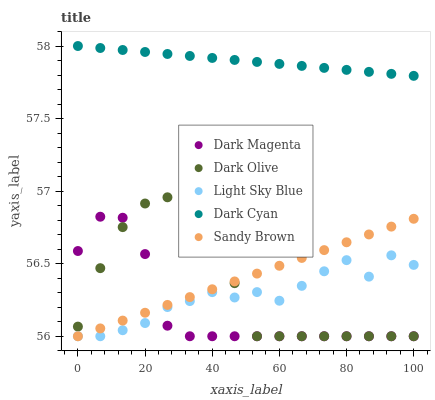Does Dark Magenta have the minimum area under the curve?
Answer yes or no. Yes. Does Dark Cyan have the maximum area under the curve?
Answer yes or no. Yes. Does Dark Olive have the minimum area under the curve?
Answer yes or no. No. Does Dark Olive have the maximum area under the curve?
Answer yes or no. No. Is Sandy Brown the smoothest?
Answer yes or no. Yes. Is Light Sky Blue the roughest?
Answer yes or no. Yes. Is Dark Olive the smoothest?
Answer yes or no. No. Is Dark Olive the roughest?
Answer yes or no. No. Does Dark Olive have the lowest value?
Answer yes or no. Yes. Does Dark Cyan have the highest value?
Answer yes or no. Yes. Does Dark Olive have the highest value?
Answer yes or no. No. Is Dark Olive less than Dark Cyan?
Answer yes or no. Yes. Is Dark Cyan greater than Dark Magenta?
Answer yes or no. Yes. Does Light Sky Blue intersect Sandy Brown?
Answer yes or no. Yes. Is Light Sky Blue less than Sandy Brown?
Answer yes or no. No. Is Light Sky Blue greater than Sandy Brown?
Answer yes or no. No. Does Dark Olive intersect Dark Cyan?
Answer yes or no. No. 